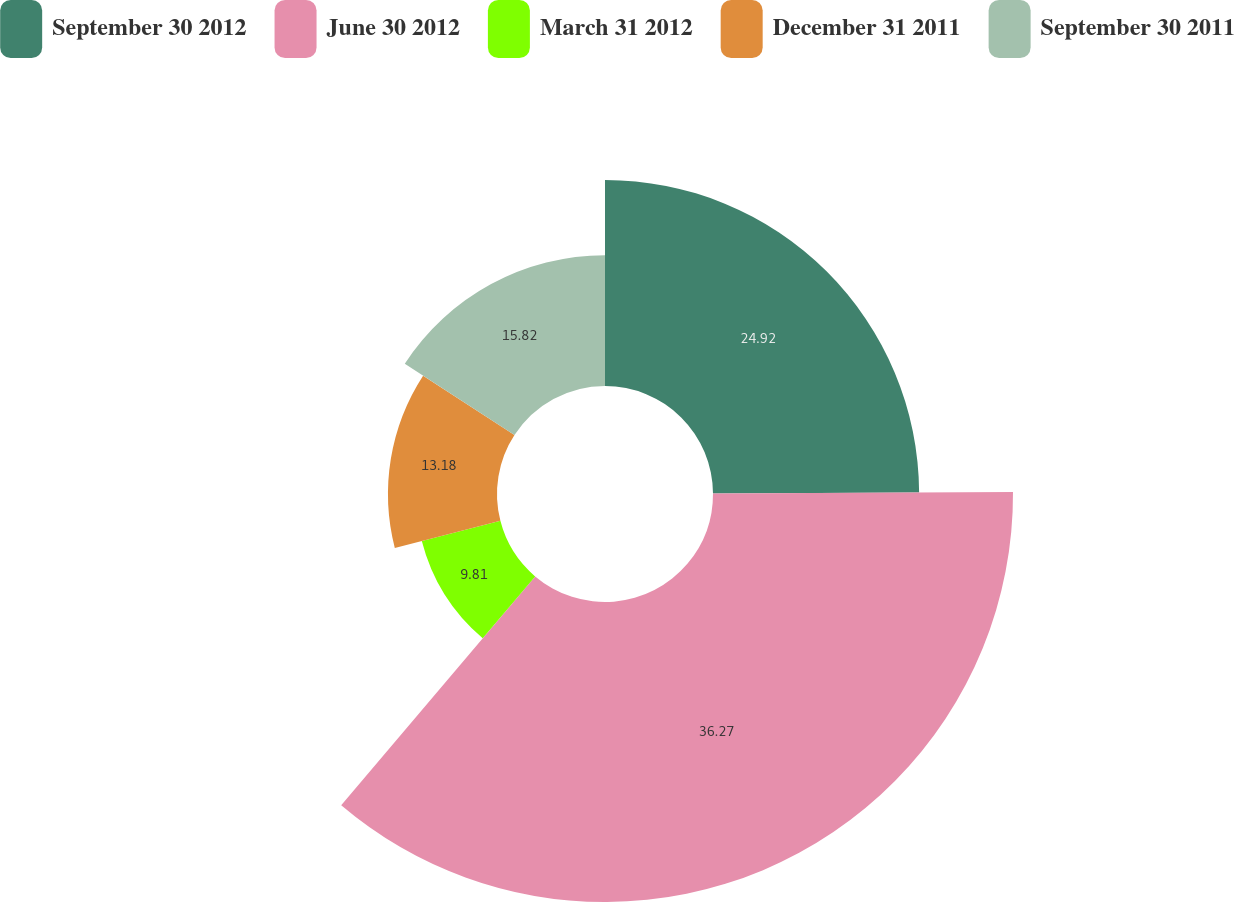Convert chart to OTSL. <chart><loc_0><loc_0><loc_500><loc_500><pie_chart><fcel>September 30 2012<fcel>June 30 2012<fcel>March 31 2012<fcel>December 31 2011<fcel>September 30 2011<nl><fcel>24.92%<fcel>36.27%<fcel>9.81%<fcel>13.18%<fcel>15.82%<nl></chart> 